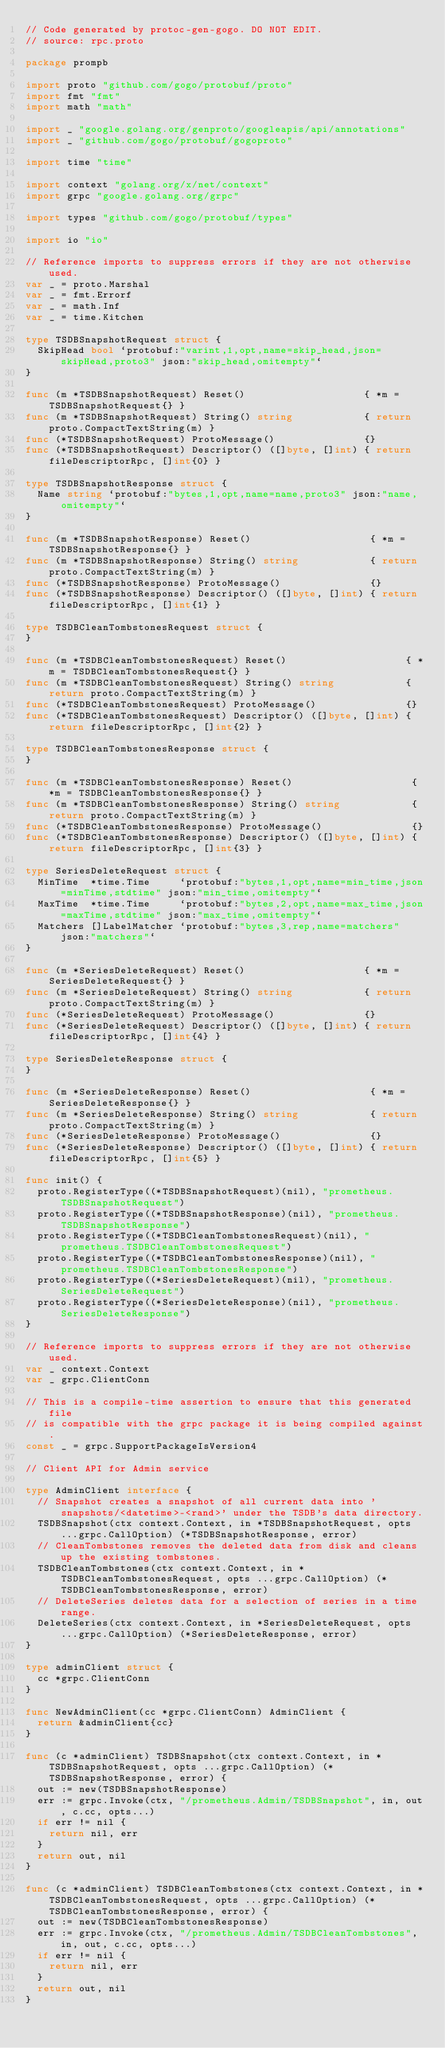<code> <loc_0><loc_0><loc_500><loc_500><_Go_>// Code generated by protoc-gen-gogo. DO NOT EDIT.
// source: rpc.proto

package prompb

import proto "github.com/gogo/protobuf/proto"
import fmt "fmt"
import math "math"

import _ "google.golang.org/genproto/googleapis/api/annotations"
import _ "github.com/gogo/protobuf/gogoproto"

import time "time"

import context "golang.org/x/net/context"
import grpc "google.golang.org/grpc"

import types "github.com/gogo/protobuf/types"

import io "io"

// Reference imports to suppress errors if they are not otherwise used.
var _ = proto.Marshal
var _ = fmt.Errorf
var _ = math.Inf
var _ = time.Kitchen

type TSDBSnapshotRequest struct {
	SkipHead bool `protobuf:"varint,1,opt,name=skip_head,json=skipHead,proto3" json:"skip_head,omitempty"`
}

func (m *TSDBSnapshotRequest) Reset()                    { *m = TSDBSnapshotRequest{} }
func (m *TSDBSnapshotRequest) String() string            { return proto.CompactTextString(m) }
func (*TSDBSnapshotRequest) ProtoMessage()               {}
func (*TSDBSnapshotRequest) Descriptor() ([]byte, []int) { return fileDescriptorRpc, []int{0} }

type TSDBSnapshotResponse struct {
	Name string `protobuf:"bytes,1,opt,name=name,proto3" json:"name,omitempty"`
}

func (m *TSDBSnapshotResponse) Reset()                    { *m = TSDBSnapshotResponse{} }
func (m *TSDBSnapshotResponse) String() string            { return proto.CompactTextString(m) }
func (*TSDBSnapshotResponse) ProtoMessage()               {}
func (*TSDBSnapshotResponse) Descriptor() ([]byte, []int) { return fileDescriptorRpc, []int{1} }

type TSDBCleanTombstonesRequest struct {
}

func (m *TSDBCleanTombstonesRequest) Reset()                    { *m = TSDBCleanTombstonesRequest{} }
func (m *TSDBCleanTombstonesRequest) String() string            { return proto.CompactTextString(m) }
func (*TSDBCleanTombstonesRequest) ProtoMessage()               {}
func (*TSDBCleanTombstonesRequest) Descriptor() ([]byte, []int) { return fileDescriptorRpc, []int{2} }

type TSDBCleanTombstonesResponse struct {
}

func (m *TSDBCleanTombstonesResponse) Reset()                    { *m = TSDBCleanTombstonesResponse{} }
func (m *TSDBCleanTombstonesResponse) String() string            { return proto.CompactTextString(m) }
func (*TSDBCleanTombstonesResponse) ProtoMessage()               {}
func (*TSDBCleanTombstonesResponse) Descriptor() ([]byte, []int) { return fileDescriptorRpc, []int{3} }

type SeriesDeleteRequest struct {
	MinTime  *time.Time     `protobuf:"bytes,1,opt,name=min_time,json=minTime,stdtime" json:"min_time,omitempty"`
	MaxTime  *time.Time     `protobuf:"bytes,2,opt,name=max_time,json=maxTime,stdtime" json:"max_time,omitempty"`
	Matchers []LabelMatcher `protobuf:"bytes,3,rep,name=matchers" json:"matchers"`
}

func (m *SeriesDeleteRequest) Reset()                    { *m = SeriesDeleteRequest{} }
func (m *SeriesDeleteRequest) String() string            { return proto.CompactTextString(m) }
func (*SeriesDeleteRequest) ProtoMessage()               {}
func (*SeriesDeleteRequest) Descriptor() ([]byte, []int) { return fileDescriptorRpc, []int{4} }

type SeriesDeleteResponse struct {
}

func (m *SeriesDeleteResponse) Reset()                    { *m = SeriesDeleteResponse{} }
func (m *SeriesDeleteResponse) String() string            { return proto.CompactTextString(m) }
func (*SeriesDeleteResponse) ProtoMessage()               {}
func (*SeriesDeleteResponse) Descriptor() ([]byte, []int) { return fileDescriptorRpc, []int{5} }

func init() {
	proto.RegisterType((*TSDBSnapshotRequest)(nil), "prometheus.TSDBSnapshotRequest")
	proto.RegisterType((*TSDBSnapshotResponse)(nil), "prometheus.TSDBSnapshotResponse")
	proto.RegisterType((*TSDBCleanTombstonesRequest)(nil), "prometheus.TSDBCleanTombstonesRequest")
	proto.RegisterType((*TSDBCleanTombstonesResponse)(nil), "prometheus.TSDBCleanTombstonesResponse")
	proto.RegisterType((*SeriesDeleteRequest)(nil), "prometheus.SeriesDeleteRequest")
	proto.RegisterType((*SeriesDeleteResponse)(nil), "prometheus.SeriesDeleteResponse")
}

// Reference imports to suppress errors if they are not otherwise used.
var _ context.Context
var _ grpc.ClientConn

// This is a compile-time assertion to ensure that this generated file
// is compatible with the grpc package it is being compiled against.
const _ = grpc.SupportPackageIsVersion4

// Client API for Admin service

type AdminClient interface {
	// Snapshot creates a snapshot of all current data into 'snapshots/<datetime>-<rand>' under the TSDB's data directory.
	TSDBSnapshot(ctx context.Context, in *TSDBSnapshotRequest, opts ...grpc.CallOption) (*TSDBSnapshotResponse, error)
	// CleanTombstones removes the deleted data from disk and cleans up the existing tombstones.
	TSDBCleanTombstones(ctx context.Context, in *TSDBCleanTombstonesRequest, opts ...grpc.CallOption) (*TSDBCleanTombstonesResponse, error)
	// DeleteSeries deletes data for a selection of series in a time range.
	DeleteSeries(ctx context.Context, in *SeriesDeleteRequest, opts ...grpc.CallOption) (*SeriesDeleteResponse, error)
}

type adminClient struct {
	cc *grpc.ClientConn
}

func NewAdminClient(cc *grpc.ClientConn) AdminClient {
	return &adminClient{cc}
}

func (c *adminClient) TSDBSnapshot(ctx context.Context, in *TSDBSnapshotRequest, opts ...grpc.CallOption) (*TSDBSnapshotResponse, error) {
	out := new(TSDBSnapshotResponse)
	err := grpc.Invoke(ctx, "/prometheus.Admin/TSDBSnapshot", in, out, c.cc, opts...)
	if err != nil {
		return nil, err
	}
	return out, nil
}

func (c *adminClient) TSDBCleanTombstones(ctx context.Context, in *TSDBCleanTombstonesRequest, opts ...grpc.CallOption) (*TSDBCleanTombstonesResponse, error) {
	out := new(TSDBCleanTombstonesResponse)
	err := grpc.Invoke(ctx, "/prometheus.Admin/TSDBCleanTombstones", in, out, c.cc, opts...)
	if err != nil {
		return nil, err
	}
	return out, nil
}
</code> 